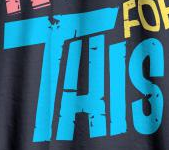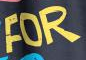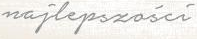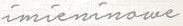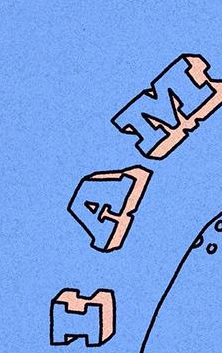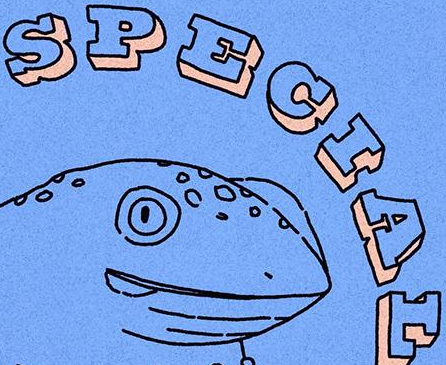Read the text content from these images in order, separated by a semicolon. THIS; FOR; najlepszości; imieninowe; IAM; SPECIAL 